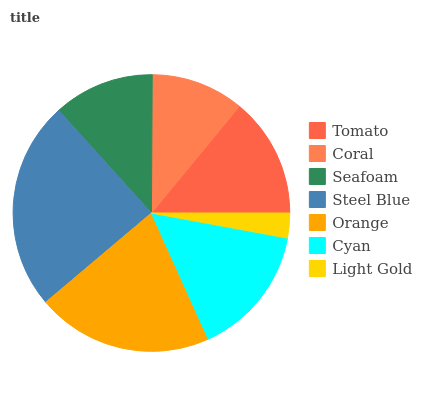Is Light Gold the minimum?
Answer yes or no. Yes. Is Steel Blue the maximum?
Answer yes or no. Yes. Is Coral the minimum?
Answer yes or no. No. Is Coral the maximum?
Answer yes or no. No. Is Tomato greater than Coral?
Answer yes or no. Yes. Is Coral less than Tomato?
Answer yes or no. Yes. Is Coral greater than Tomato?
Answer yes or no. No. Is Tomato less than Coral?
Answer yes or no. No. Is Tomato the high median?
Answer yes or no. Yes. Is Tomato the low median?
Answer yes or no. Yes. Is Coral the high median?
Answer yes or no. No. Is Light Gold the low median?
Answer yes or no. No. 